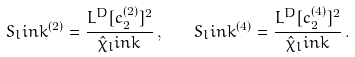<formula> <loc_0><loc_0><loc_500><loc_500>S _ { l } i n k ^ { ( 2 ) } = \frac { L ^ { D } [ c _ { 2 } ^ { ( 2 ) } ] ^ { 2 } } { \hat { \chi } _ { l } i n k } \, , \quad S _ { l } i n k ^ { ( 4 ) } = \frac { L ^ { D } [ c _ { 2 } ^ { ( 4 ) } ] ^ { 2 } } { \hat { \chi } _ { l } i n k } \, .</formula> 